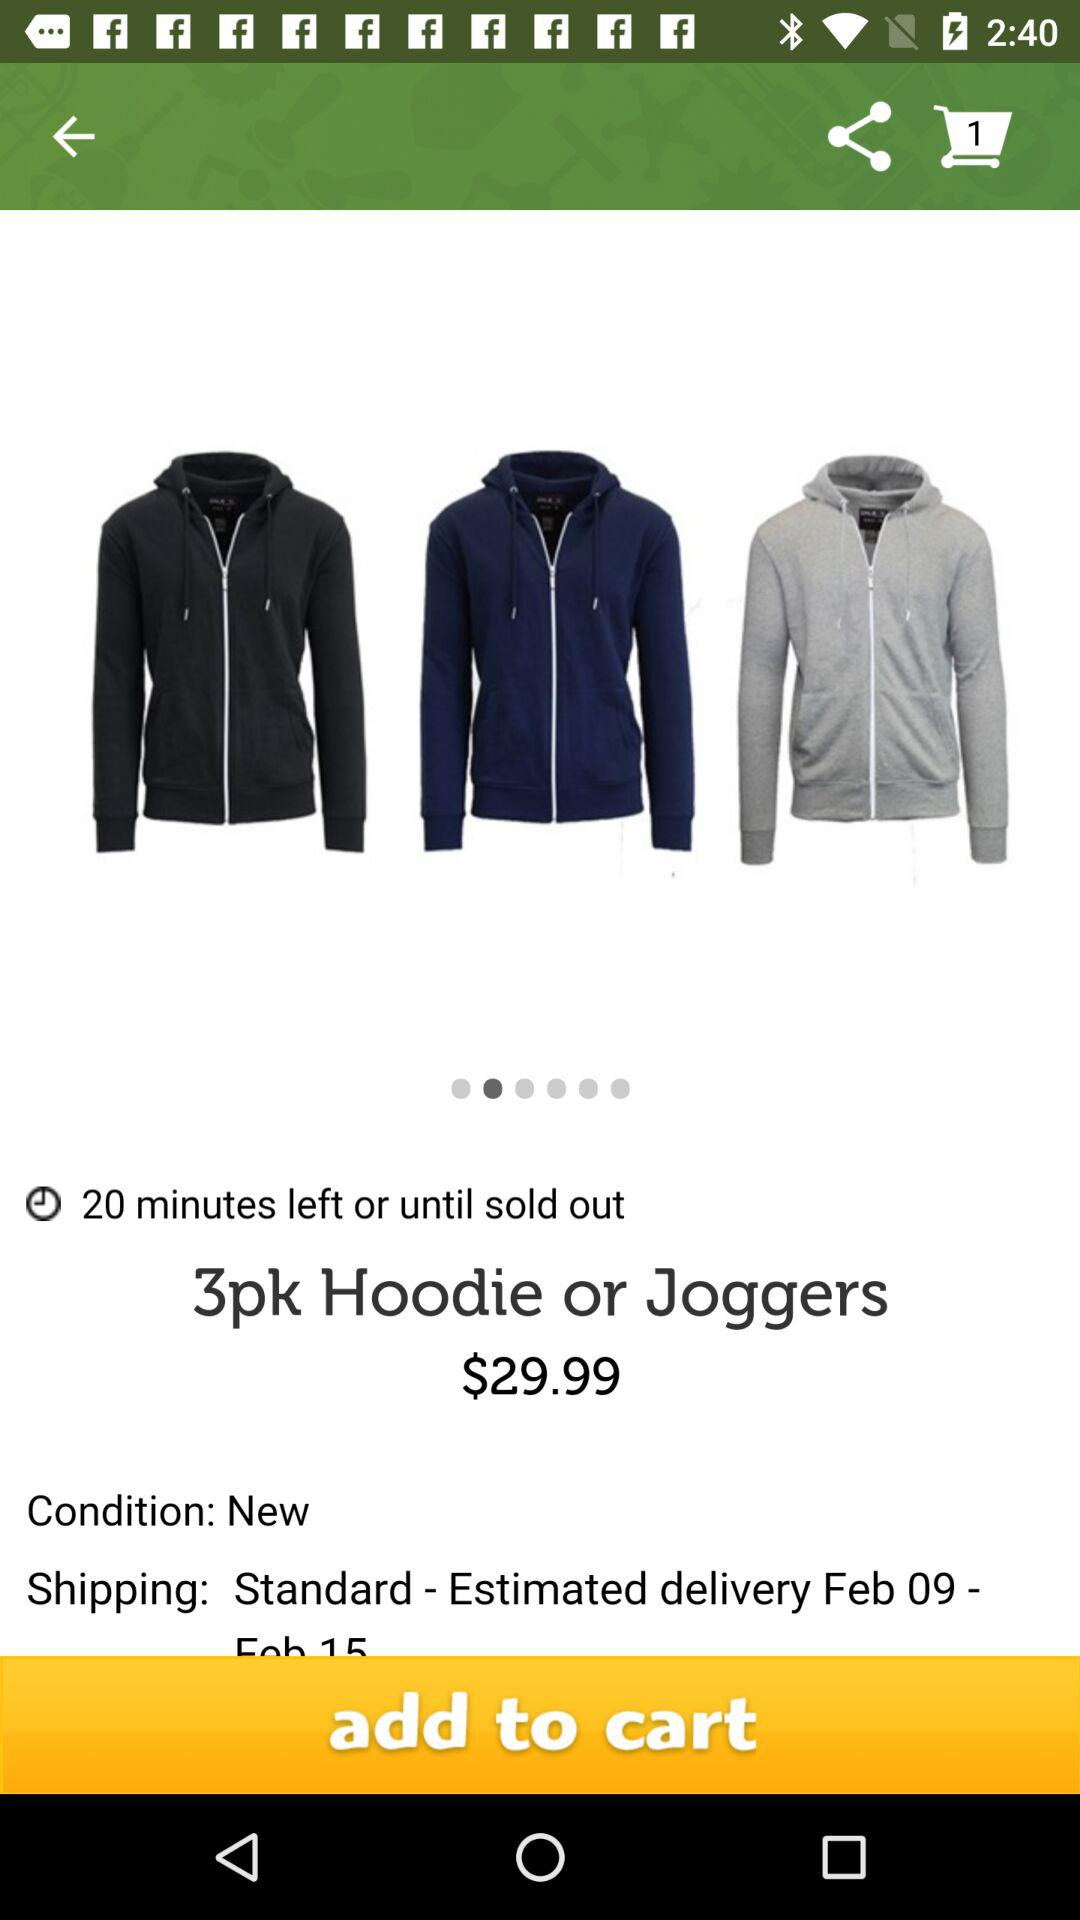How much time is left until the product is sold out? There are 20 minutes left until the product is sold out. 